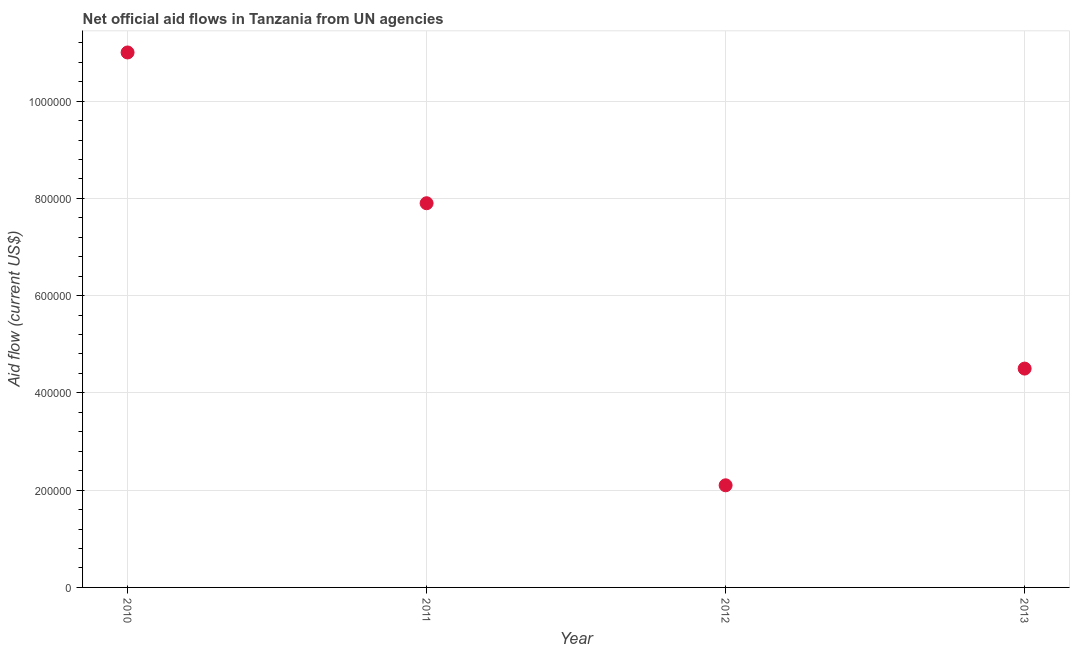What is the net official flows from un agencies in 2011?
Provide a succinct answer. 7.90e+05. Across all years, what is the maximum net official flows from un agencies?
Ensure brevity in your answer.  1.10e+06. Across all years, what is the minimum net official flows from un agencies?
Keep it short and to the point. 2.10e+05. In which year was the net official flows from un agencies minimum?
Keep it short and to the point. 2012. What is the sum of the net official flows from un agencies?
Ensure brevity in your answer.  2.55e+06. What is the difference between the net official flows from un agencies in 2011 and 2012?
Your answer should be very brief. 5.80e+05. What is the average net official flows from un agencies per year?
Give a very brief answer. 6.38e+05. What is the median net official flows from un agencies?
Offer a terse response. 6.20e+05. In how many years, is the net official flows from un agencies greater than 600000 US$?
Offer a very short reply. 2. What is the ratio of the net official flows from un agencies in 2010 to that in 2011?
Your answer should be compact. 1.39. Is the sum of the net official flows from un agencies in 2011 and 2013 greater than the maximum net official flows from un agencies across all years?
Your answer should be compact. Yes. What is the difference between the highest and the lowest net official flows from un agencies?
Provide a short and direct response. 8.90e+05. Does the net official flows from un agencies monotonically increase over the years?
Offer a very short reply. No. How many years are there in the graph?
Provide a succinct answer. 4. What is the difference between two consecutive major ticks on the Y-axis?
Make the answer very short. 2.00e+05. Does the graph contain grids?
Provide a short and direct response. Yes. What is the title of the graph?
Your response must be concise. Net official aid flows in Tanzania from UN agencies. What is the Aid flow (current US$) in 2010?
Ensure brevity in your answer.  1.10e+06. What is the Aid flow (current US$) in 2011?
Offer a terse response. 7.90e+05. What is the Aid flow (current US$) in 2012?
Offer a very short reply. 2.10e+05. What is the Aid flow (current US$) in 2013?
Provide a short and direct response. 4.50e+05. What is the difference between the Aid flow (current US$) in 2010 and 2012?
Your response must be concise. 8.90e+05. What is the difference between the Aid flow (current US$) in 2010 and 2013?
Offer a terse response. 6.50e+05. What is the difference between the Aid flow (current US$) in 2011 and 2012?
Offer a terse response. 5.80e+05. What is the ratio of the Aid flow (current US$) in 2010 to that in 2011?
Provide a short and direct response. 1.39. What is the ratio of the Aid flow (current US$) in 2010 to that in 2012?
Provide a succinct answer. 5.24. What is the ratio of the Aid flow (current US$) in 2010 to that in 2013?
Offer a very short reply. 2.44. What is the ratio of the Aid flow (current US$) in 2011 to that in 2012?
Offer a very short reply. 3.76. What is the ratio of the Aid flow (current US$) in 2011 to that in 2013?
Your answer should be very brief. 1.76. What is the ratio of the Aid flow (current US$) in 2012 to that in 2013?
Keep it short and to the point. 0.47. 